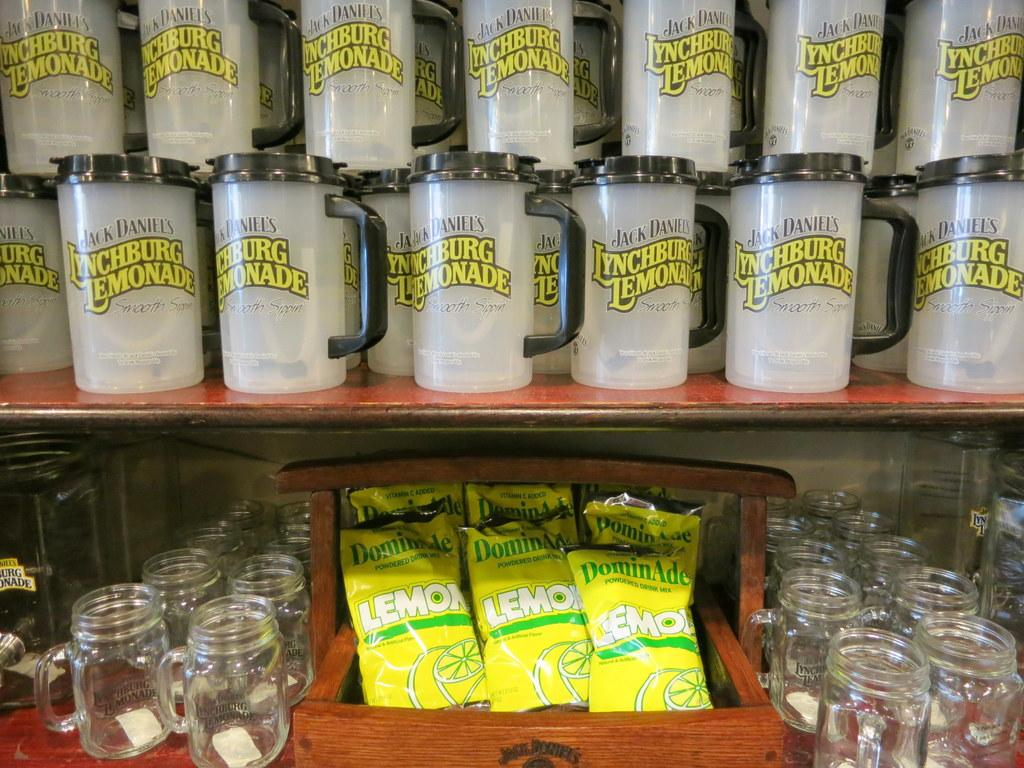<image>
Describe the image concisely. shelf with mugs for jack daniels lynchburg lemonade and lower shelf with jars and bags of dominade lemols 